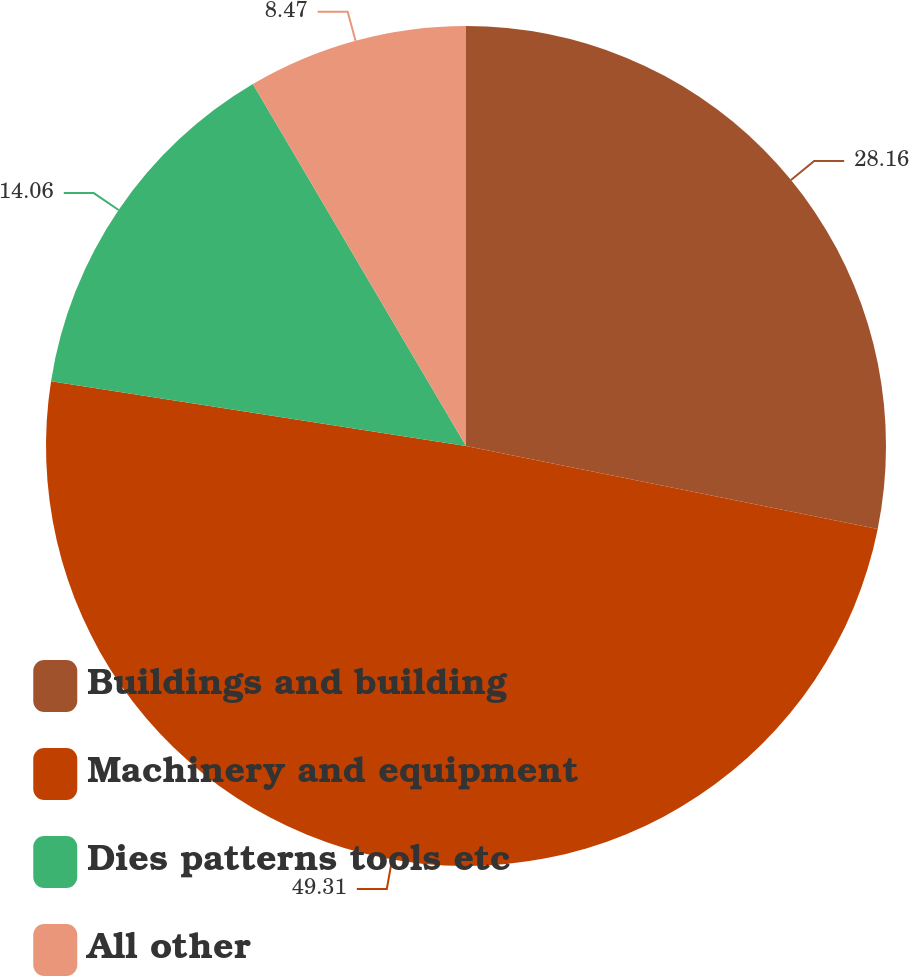<chart> <loc_0><loc_0><loc_500><loc_500><pie_chart><fcel>Buildings and building<fcel>Machinery and equipment<fcel>Dies patterns tools etc<fcel>All other<nl><fcel>28.16%<fcel>49.3%<fcel>14.06%<fcel>8.47%<nl></chart> 